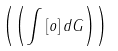<formula> <loc_0><loc_0><loc_500><loc_500>\left ( \left ( \int \left [ o \right ] d G \right ) \right )</formula> 